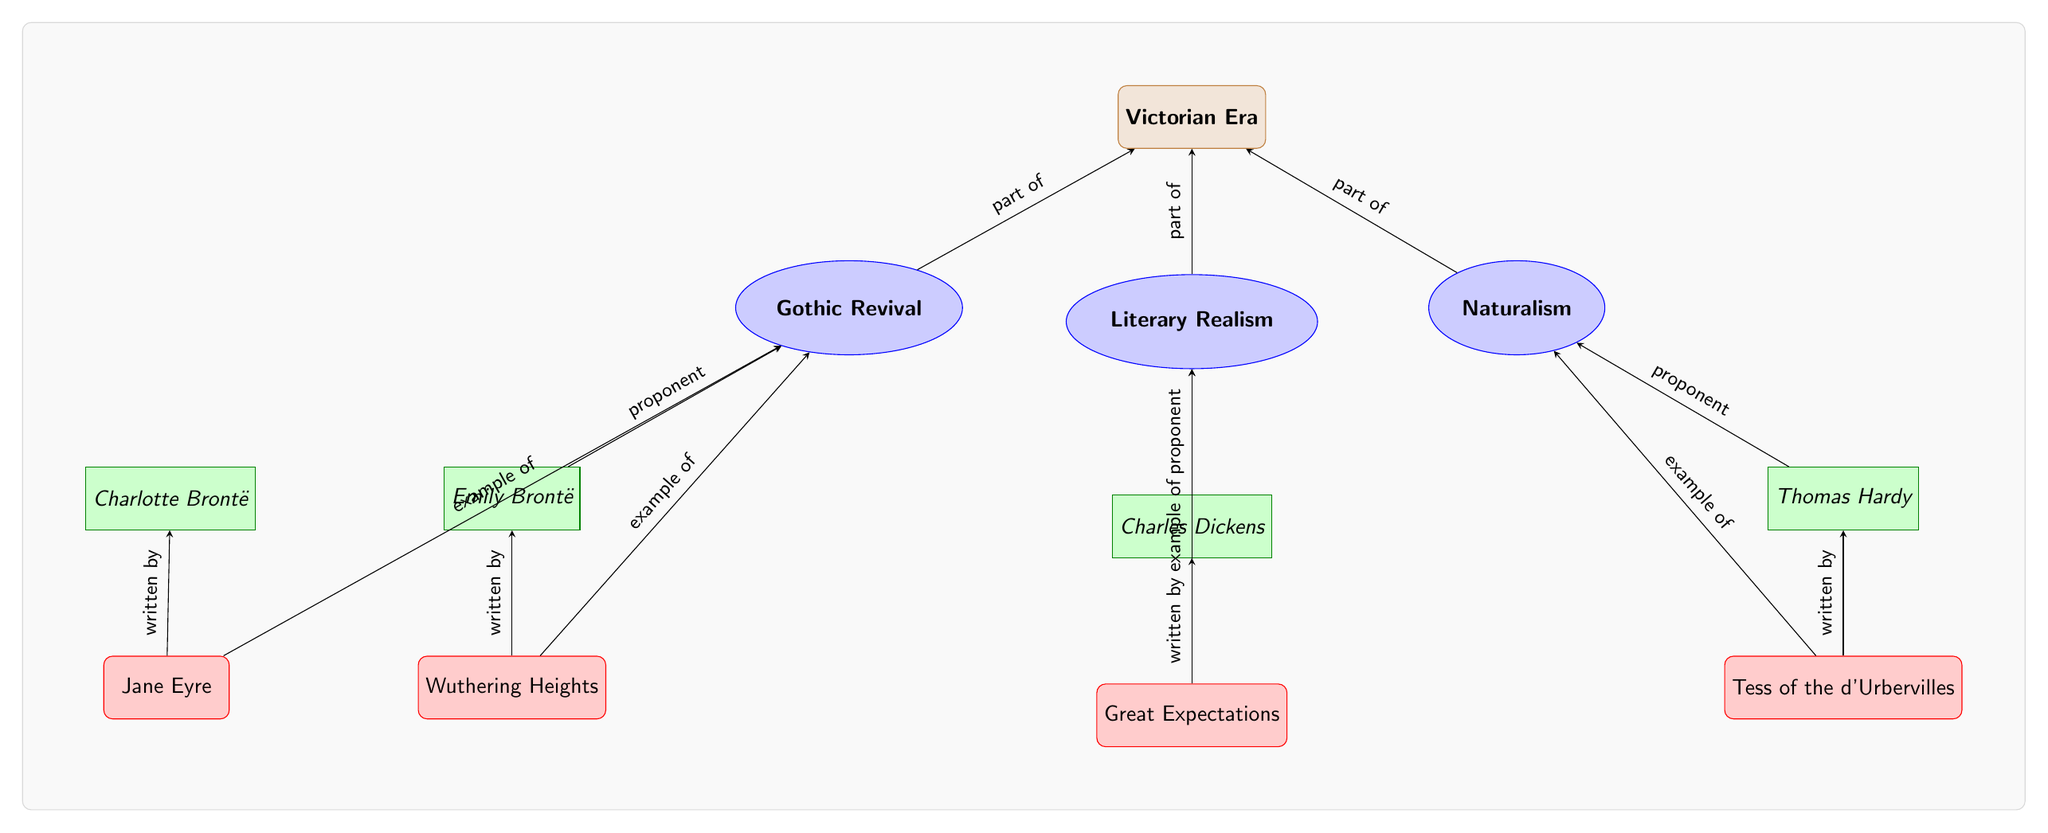What is the main era depicted in the diagram? The diagram begins with the node labeled "Victorian Era," indicating this is the primary focus of the diagram.
Answer: Victorian Era How many literary movements are illustrated? The diagram shows three distinct musical movements: Gothic Revival, Literary Realism, and Naturalism, which can be counted directly from the movements' nodes.
Answer: 3 Who wrote "Great Expectations"? The diagram connects "Great Expectations" to the author node "Charles Dickens," showing that he is the writer of this work.
Answer: Charles Dickens What type of relationship exists between "Emily Brontë" and "Wuthering Heights"? The diagram indicates that "Emily Brontë" is connected to "Wuthering Heights" with a directed edge labeled "written by," signifying authorship.
Answer: written by Which literary movement is "Tess of the d'Urbervilles" associated with? Observing the diagram, "Tess of the d'Urbervilles" is directly linked to the "Naturalism" movement, showing this is its associated literary category.
Answer: Naturalism Who is a proponent of Literary Realism? The diagram shows an edge connecting "Charles Dickens" to "Literary Realism" with the label "proponent," indicating his affiliation with this movement.
Answer: Charles Dickens What works are categorized under Gothic Revival? Both "Wuthering Heights" and "Jane Eyre" are directly connected to "Gothic Revival," which indicates they exemplify this literary movement.
Answer: Wuthering Heights and Jane Eyre Which author is linked to "Jane Eyre"? The diagram illustrates a direct connection from "Charlotte Brontë" to "Jane Eyre," indicating her role as the author of this work.
Answer: Charlotte Brontë How does "Naturalism" relate to the Victorian Era? The edge labeled "part of" connects "Naturalism" to "Victorian Era," indicating that it is a literary movement belonging to this larger time period.
Answer: part of 